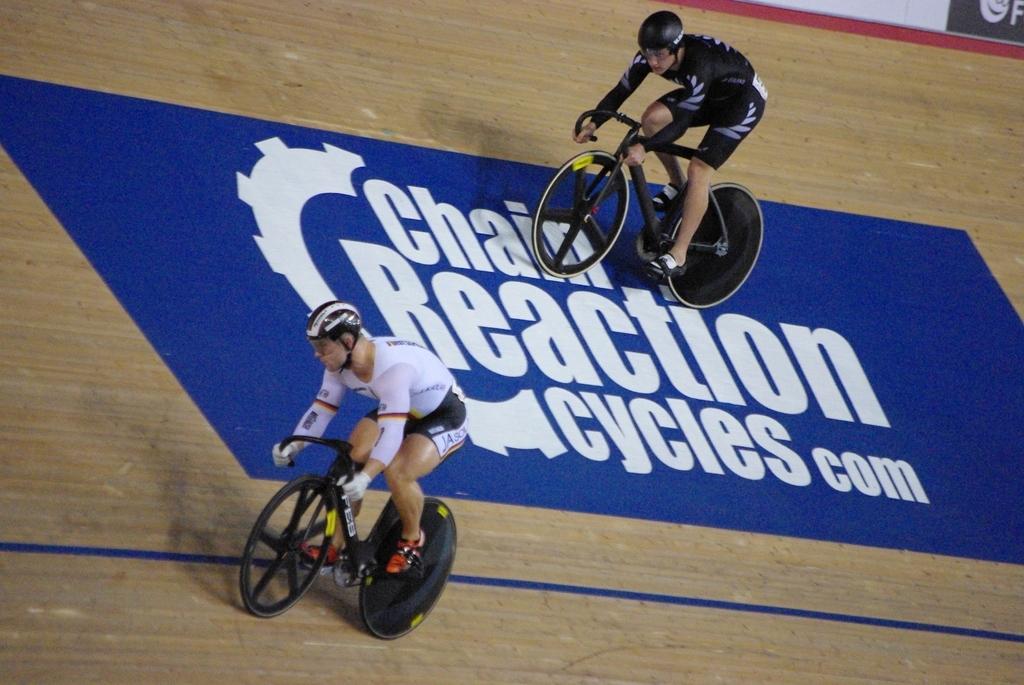<image>
Describe the image concisely. A bike track that says Chain Reaction Cycles com on it. 